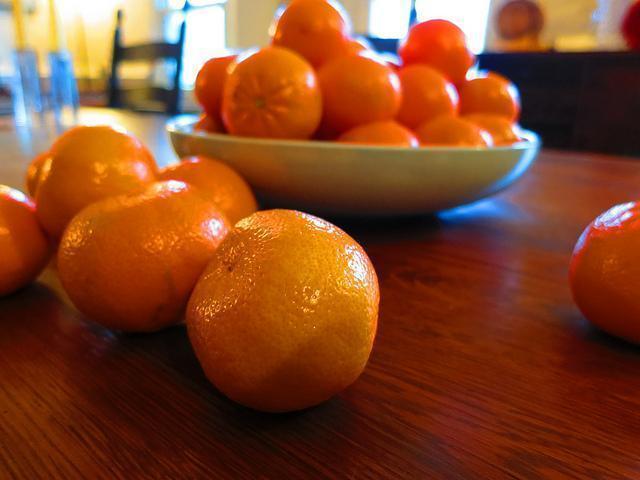What utensil is usually needed with this food?
From the following set of four choices, select the accurate answer to respond to the question.
Options: Knife, pitchfork, spatula, chopstick. Knife. 